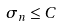<formula> <loc_0><loc_0><loc_500><loc_500>\sigma _ { n } \leq C</formula> 